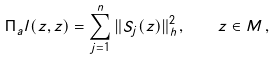Convert formula to latex. <formula><loc_0><loc_0><loc_500><loc_500>\Pi _ { a } l ( z , z ) = \sum _ { j = 1 } ^ { n } \| S _ { j } ( z ) \| _ { h } ^ { 2 } \, , \quad z \in M \, ,</formula> 